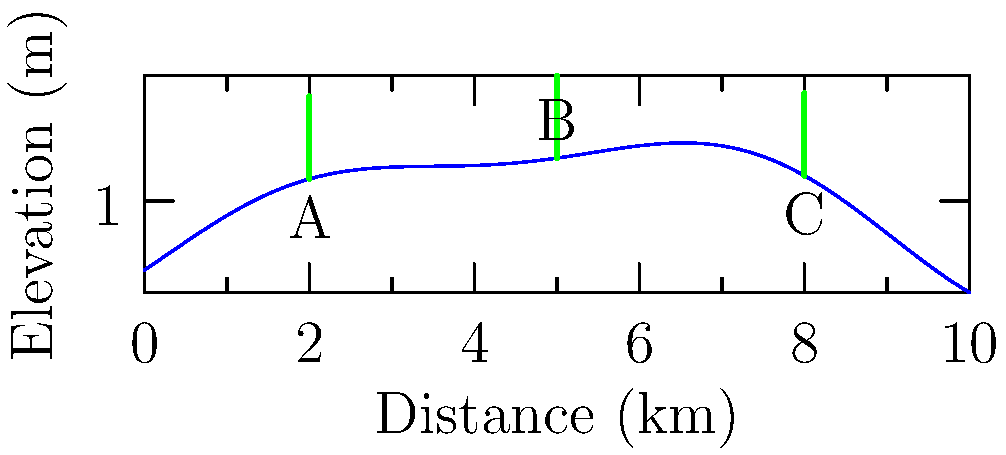Based on the topographical map showing three potential wind turbine locations (A, B, and C), which location would likely provide the highest wind energy output? Consider factors such as elevation and terrain effects on wind speed. To determine the optimal wind turbine placement, we need to consider several factors:

1. Elevation: Higher elevations generally experience stronger and more consistent winds.
2. Terrain effects: The shape of the terrain can affect wind speed and turbulence.

Analyzing each location:

A. Low elevation, on the windward side of a hill. This position may benefit from some wind acceleration as air moves up the slope, but it's not at the optimal height.

B. Highest elevation among the three options. This location is at the peak of the hill, which typically experiences the strongest and most consistent winds due to:
   a) Less surface friction at higher altitudes
   b) Wind speed-up effect as air compresses while moving over the hill

C. Medium elevation, on the leeward side of the hill. This position may experience turbulent or slower winds due to the sheltering effect of the hill.

Given these considerations, location B is likely to provide the highest wind energy output due to its superior elevation and position at the hill's peak, where wind speeds are typically highest and most consistent.
Answer: Location B 